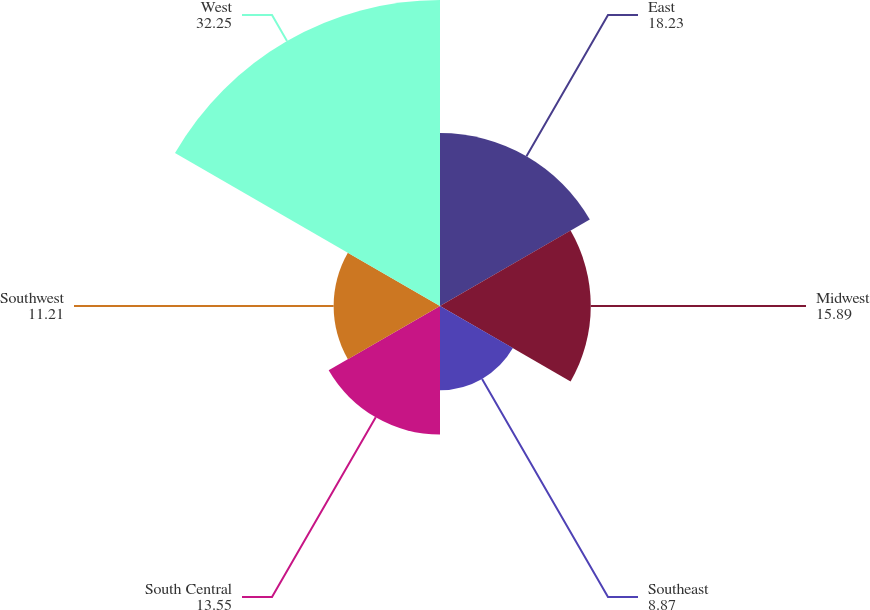Convert chart to OTSL. <chart><loc_0><loc_0><loc_500><loc_500><pie_chart><fcel>East<fcel>Midwest<fcel>Southeast<fcel>South Central<fcel>Southwest<fcel>West<nl><fcel>18.23%<fcel>15.89%<fcel>8.87%<fcel>13.55%<fcel>11.21%<fcel>32.25%<nl></chart> 